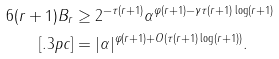Convert formula to latex. <formula><loc_0><loc_0><loc_500><loc_500>6 ( r + 1 ) B _ { r } & \geq 2 ^ { - \tau ( r + 1 ) } \alpha ^ { \varphi ( r + 1 ) - \gamma \tau ( r + 1 ) \log ( r + 1 ) } \\ [ . 3 p c ] & = | \alpha | ^ { \varphi ( r + 1 ) + O ( \tau ( r + 1 ) \log ( r + 1 ) ) } .</formula> 